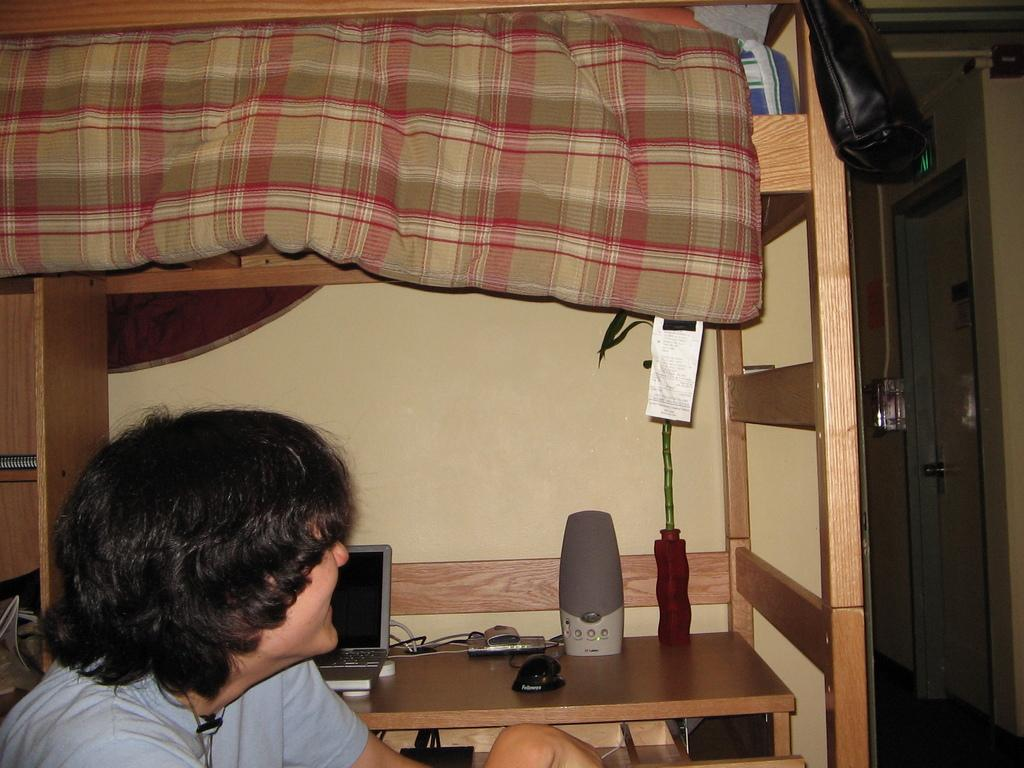What is the main subject of the image? There is a person in the image. What is in front of the person? There is a table in front of the person. What electronic device is on the table? There is a laptop on the table. What is used for controlling the laptop? There is a mouse on the table. What is used for amplifying sound on the table? There is a speaker on the table. What type of plant is on the table? The plant on the table is not specified in the facts. What type of furniture is in the image? There is a bed in the image. What architectural feature is visible in the image? There is a wall visible in the image. What type of cloth is draped over the person's hands in the image? There is no cloth or mention of hands in the image. 